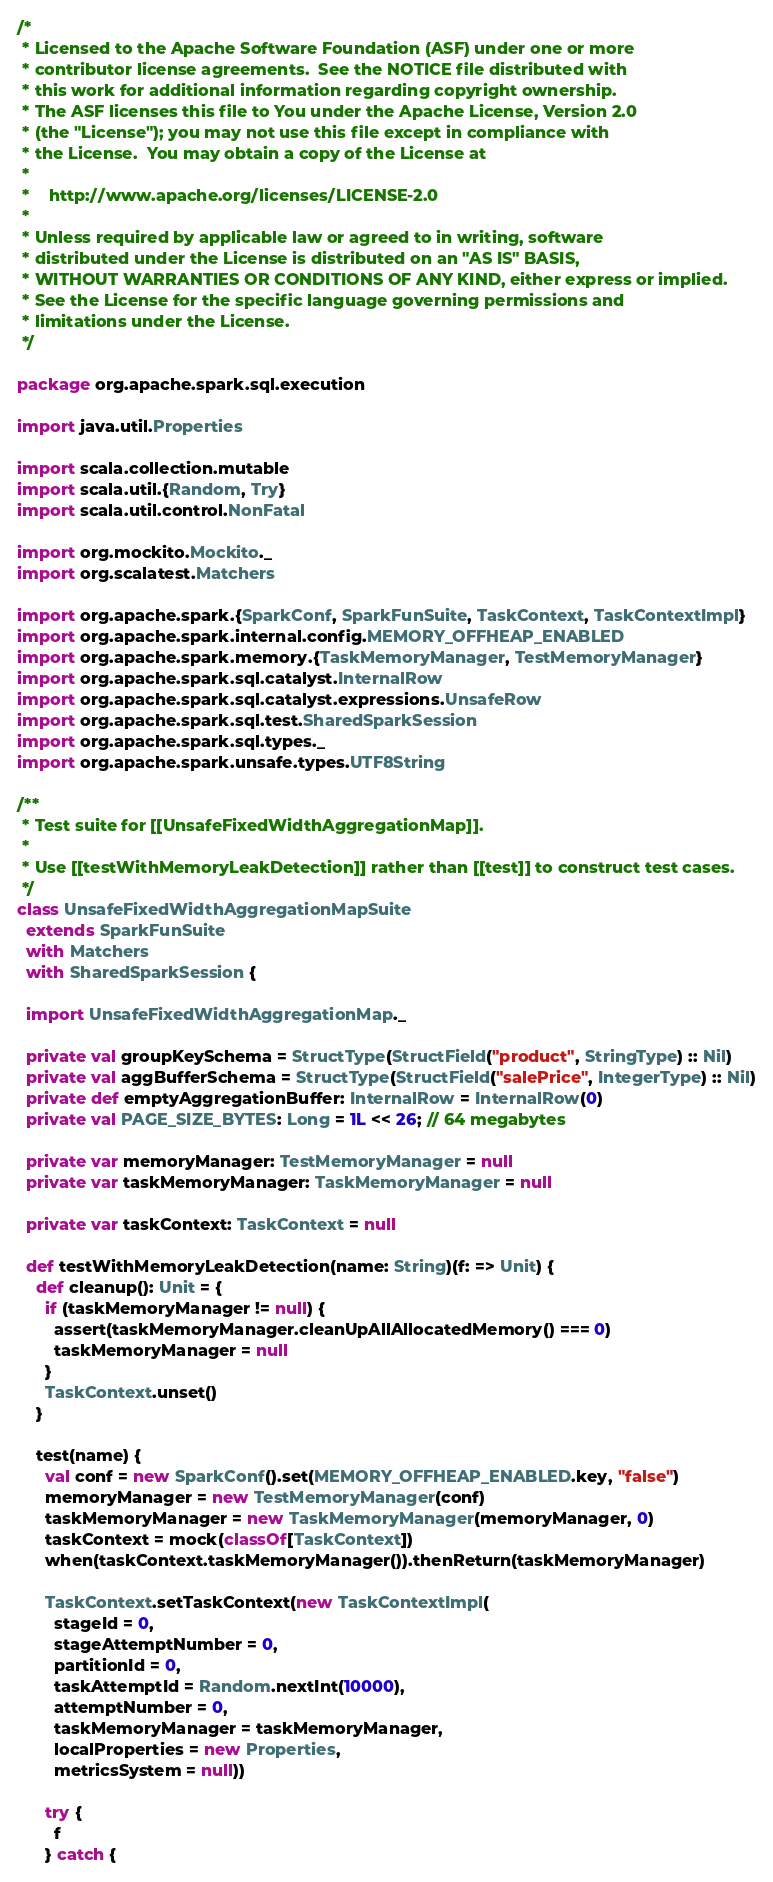Convert code to text. <code><loc_0><loc_0><loc_500><loc_500><_Scala_>/*
 * Licensed to the Apache Software Foundation (ASF) under one or more
 * contributor license agreements.  See the NOTICE file distributed with
 * this work for additional information regarding copyright ownership.
 * The ASF licenses this file to You under the Apache License, Version 2.0
 * (the "License"); you may not use this file except in compliance with
 * the License.  You may obtain a copy of the License at
 *
 *    http://www.apache.org/licenses/LICENSE-2.0
 *
 * Unless required by applicable law or agreed to in writing, software
 * distributed under the License is distributed on an "AS IS" BASIS,
 * WITHOUT WARRANTIES OR CONDITIONS OF ANY KIND, either express or implied.
 * See the License for the specific language governing permissions and
 * limitations under the License.
 */

package org.apache.spark.sql.execution

import java.util.Properties

import scala.collection.mutable
import scala.util.{Random, Try}
import scala.util.control.NonFatal

import org.mockito.Mockito._
import org.scalatest.Matchers

import org.apache.spark.{SparkConf, SparkFunSuite, TaskContext, TaskContextImpl}
import org.apache.spark.internal.config.MEMORY_OFFHEAP_ENABLED
import org.apache.spark.memory.{TaskMemoryManager, TestMemoryManager}
import org.apache.spark.sql.catalyst.InternalRow
import org.apache.spark.sql.catalyst.expressions.UnsafeRow
import org.apache.spark.sql.test.SharedSparkSession
import org.apache.spark.sql.types._
import org.apache.spark.unsafe.types.UTF8String

/**
 * Test suite for [[UnsafeFixedWidthAggregationMap]].
 *
 * Use [[testWithMemoryLeakDetection]] rather than [[test]] to construct test cases.
 */
class UnsafeFixedWidthAggregationMapSuite
  extends SparkFunSuite
  with Matchers
  with SharedSparkSession {

  import UnsafeFixedWidthAggregationMap._

  private val groupKeySchema = StructType(StructField("product", StringType) :: Nil)
  private val aggBufferSchema = StructType(StructField("salePrice", IntegerType) :: Nil)
  private def emptyAggregationBuffer: InternalRow = InternalRow(0)
  private val PAGE_SIZE_BYTES: Long = 1L << 26; // 64 megabytes

  private var memoryManager: TestMemoryManager = null
  private var taskMemoryManager: TaskMemoryManager = null

  private var taskContext: TaskContext = null

  def testWithMemoryLeakDetection(name: String)(f: => Unit) {
    def cleanup(): Unit = {
      if (taskMemoryManager != null) {
        assert(taskMemoryManager.cleanUpAllAllocatedMemory() === 0)
        taskMemoryManager = null
      }
      TaskContext.unset()
    }

    test(name) {
      val conf = new SparkConf().set(MEMORY_OFFHEAP_ENABLED.key, "false")
      memoryManager = new TestMemoryManager(conf)
      taskMemoryManager = new TaskMemoryManager(memoryManager, 0)
      taskContext = mock(classOf[TaskContext])
      when(taskContext.taskMemoryManager()).thenReturn(taskMemoryManager)

      TaskContext.setTaskContext(new TaskContextImpl(
        stageId = 0,
        stageAttemptNumber = 0,
        partitionId = 0,
        taskAttemptId = Random.nextInt(10000),
        attemptNumber = 0,
        taskMemoryManager = taskMemoryManager,
        localProperties = new Properties,
        metricsSystem = null))

      try {
        f
      } catch {</code> 